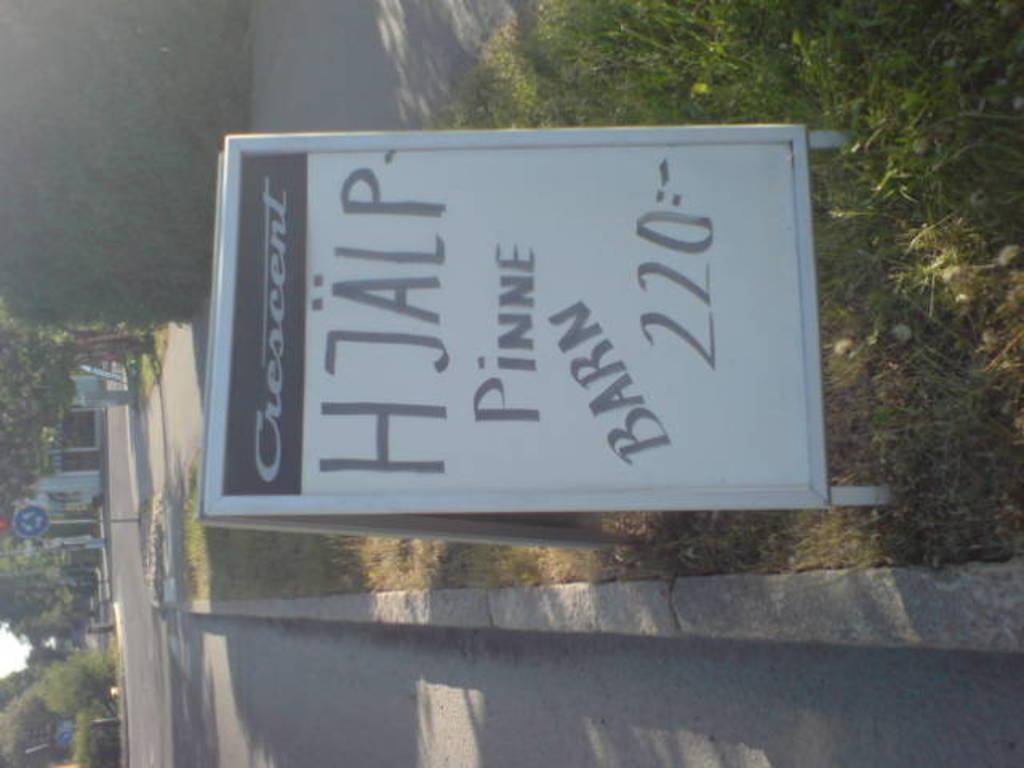Describe this image in one or two sentences. In this picture we picture we can see a sign board, in the background we can find few trees, metal rods and houses. 